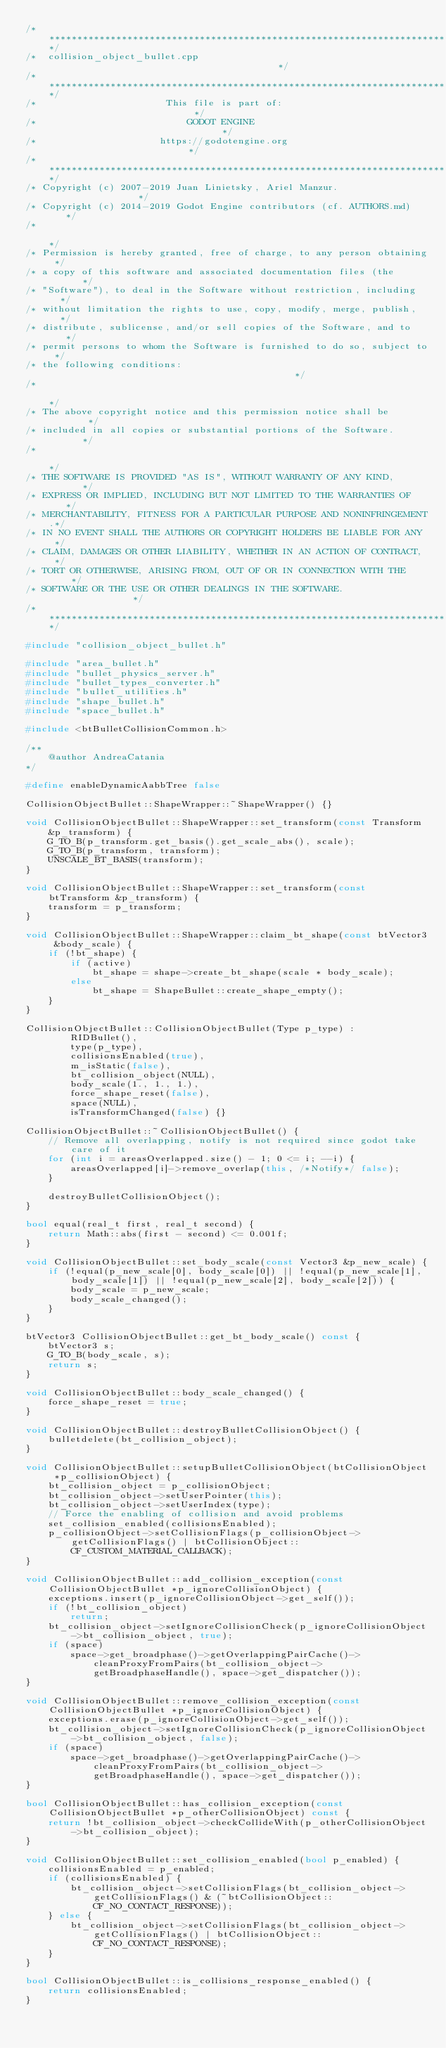<code> <loc_0><loc_0><loc_500><loc_500><_C++_>/*************************************************************************/
/*  collision_object_bullet.cpp                                          */
/*************************************************************************/
/*                       This file is part of:                           */
/*                           GODOT ENGINE                                */
/*                      https://godotengine.org                          */
/*************************************************************************/
/* Copyright (c) 2007-2019 Juan Linietsky, Ariel Manzur.                 */
/* Copyright (c) 2014-2019 Godot Engine contributors (cf. AUTHORS.md)    */
/*                                                                       */
/* Permission is hereby granted, free of charge, to any person obtaining */
/* a copy of this software and associated documentation files (the       */
/* "Software"), to deal in the Software without restriction, including   */
/* without limitation the rights to use, copy, modify, merge, publish,   */
/* distribute, sublicense, and/or sell copies of the Software, and to    */
/* permit persons to whom the Software is furnished to do so, subject to */
/* the following conditions:                                             */
/*                                                                       */
/* The above copyright notice and this permission notice shall be        */
/* included in all copies or substantial portions of the Software.       */
/*                                                                       */
/* THE SOFTWARE IS PROVIDED "AS IS", WITHOUT WARRANTY OF ANY KIND,       */
/* EXPRESS OR IMPLIED, INCLUDING BUT NOT LIMITED TO THE WARRANTIES OF    */
/* MERCHANTABILITY, FITNESS FOR A PARTICULAR PURPOSE AND NONINFRINGEMENT.*/
/* IN NO EVENT SHALL THE AUTHORS OR COPYRIGHT HOLDERS BE LIABLE FOR ANY  */
/* CLAIM, DAMAGES OR OTHER LIABILITY, WHETHER IN AN ACTION OF CONTRACT,  */
/* TORT OR OTHERWISE, ARISING FROM, OUT OF OR IN CONNECTION WITH THE     */
/* SOFTWARE OR THE USE OR OTHER DEALINGS IN THE SOFTWARE.                */
/*************************************************************************/

#include "collision_object_bullet.h"

#include "area_bullet.h"
#include "bullet_physics_server.h"
#include "bullet_types_converter.h"
#include "bullet_utilities.h"
#include "shape_bullet.h"
#include "space_bullet.h"

#include <btBulletCollisionCommon.h>

/**
	@author AndreaCatania
*/

#define enableDynamicAabbTree false

CollisionObjectBullet::ShapeWrapper::~ShapeWrapper() {}

void CollisionObjectBullet::ShapeWrapper::set_transform(const Transform &p_transform) {
	G_TO_B(p_transform.get_basis().get_scale_abs(), scale);
	G_TO_B(p_transform, transform);
	UNSCALE_BT_BASIS(transform);
}

void CollisionObjectBullet::ShapeWrapper::set_transform(const btTransform &p_transform) {
	transform = p_transform;
}

void CollisionObjectBullet::ShapeWrapper::claim_bt_shape(const btVector3 &body_scale) {
	if (!bt_shape) {
		if (active)
			bt_shape = shape->create_bt_shape(scale * body_scale);
		else
			bt_shape = ShapeBullet::create_shape_empty();
	}
}

CollisionObjectBullet::CollisionObjectBullet(Type p_type) :
		RIDBullet(),
		type(p_type),
		collisionsEnabled(true),
		m_isStatic(false),
		bt_collision_object(NULL),
		body_scale(1., 1., 1.),
		force_shape_reset(false),
		space(NULL),
		isTransformChanged(false) {}

CollisionObjectBullet::~CollisionObjectBullet() {
	// Remove all overlapping, notify is not required since godot take care of it
	for (int i = areasOverlapped.size() - 1; 0 <= i; --i) {
		areasOverlapped[i]->remove_overlap(this, /*Notify*/ false);
	}

	destroyBulletCollisionObject();
}

bool equal(real_t first, real_t second) {
	return Math::abs(first - second) <= 0.001f;
}

void CollisionObjectBullet::set_body_scale(const Vector3 &p_new_scale) {
	if (!equal(p_new_scale[0], body_scale[0]) || !equal(p_new_scale[1], body_scale[1]) || !equal(p_new_scale[2], body_scale[2])) {
		body_scale = p_new_scale;
		body_scale_changed();
	}
}

btVector3 CollisionObjectBullet::get_bt_body_scale() const {
	btVector3 s;
	G_TO_B(body_scale, s);
	return s;
}

void CollisionObjectBullet::body_scale_changed() {
	force_shape_reset = true;
}

void CollisionObjectBullet::destroyBulletCollisionObject() {
	bulletdelete(bt_collision_object);
}

void CollisionObjectBullet::setupBulletCollisionObject(btCollisionObject *p_collisionObject) {
	bt_collision_object = p_collisionObject;
	bt_collision_object->setUserPointer(this);
	bt_collision_object->setUserIndex(type);
	// Force the enabling of collision and avoid problems
	set_collision_enabled(collisionsEnabled);
	p_collisionObject->setCollisionFlags(p_collisionObject->getCollisionFlags() | btCollisionObject::CF_CUSTOM_MATERIAL_CALLBACK);
}

void CollisionObjectBullet::add_collision_exception(const CollisionObjectBullet *p_ignoreCollisionObject) {
	exceptions.insert(p_ignoreCollisionObject->get_self());
	if (!bt_collision_object)
		return;
	bt_collision_object->setIgnoreCollisionCheck(p_ignoreCollisionObject->bt_collision_object, true);
	if (space)
		space->get_broadphase()->getOverlappingPairCache()->cleanProxyFromPairs(bt_collision_object->getBroadphaseHandle(), space->get_dispatcher());
}

void CollisionObjectBullet::remove_collision_exception(const CollisionObjectBullet *p_ignoreCollisionObject) {
	exceptions.erase(p_ignoreCollisionObject->get_self());
	bt_collision_object->setIgnoreCollisionCheck(p_ignoreCollisionObject->bt_collision_object, false);
	if (space)
		space->get_broadphase()->getOverlappingPairCache()->cleanProxyFromPairs(bt_collision_object->getBroadphaseHandle(), space->get_dispatcher());
}

bool CollisionObjectBullet::has_collision_exception(const CollisionObjectBullet *p_otherCollisionObject) const {
	return !bt_collision_object->checkCollideWith(p_otherCollisionObject->bt_collision_object);
}

void CollisionObjectBullet::set_collision_enabled(bool p_enabled) {
	collisionsEnabled = p_enabled;
	if (collisionsEnabled) {
		bt_collision_object->setCollisionFlags(bt_collision_object->getCollisionFlags() & (~btCollisionObject::CF_NO_CONTACT_RESPONSE));
	} else {
		bt_collision_object->setCollisionFlags(bt_collision_object->getCollisionFlags() | btCollisionObject::CF_NO_CONTACT_RESPONSE);
	}
}

bool CollisionObjectBullet::is_collisions_response_enabled() {
	return collisionsEnabled;
}
</code> 